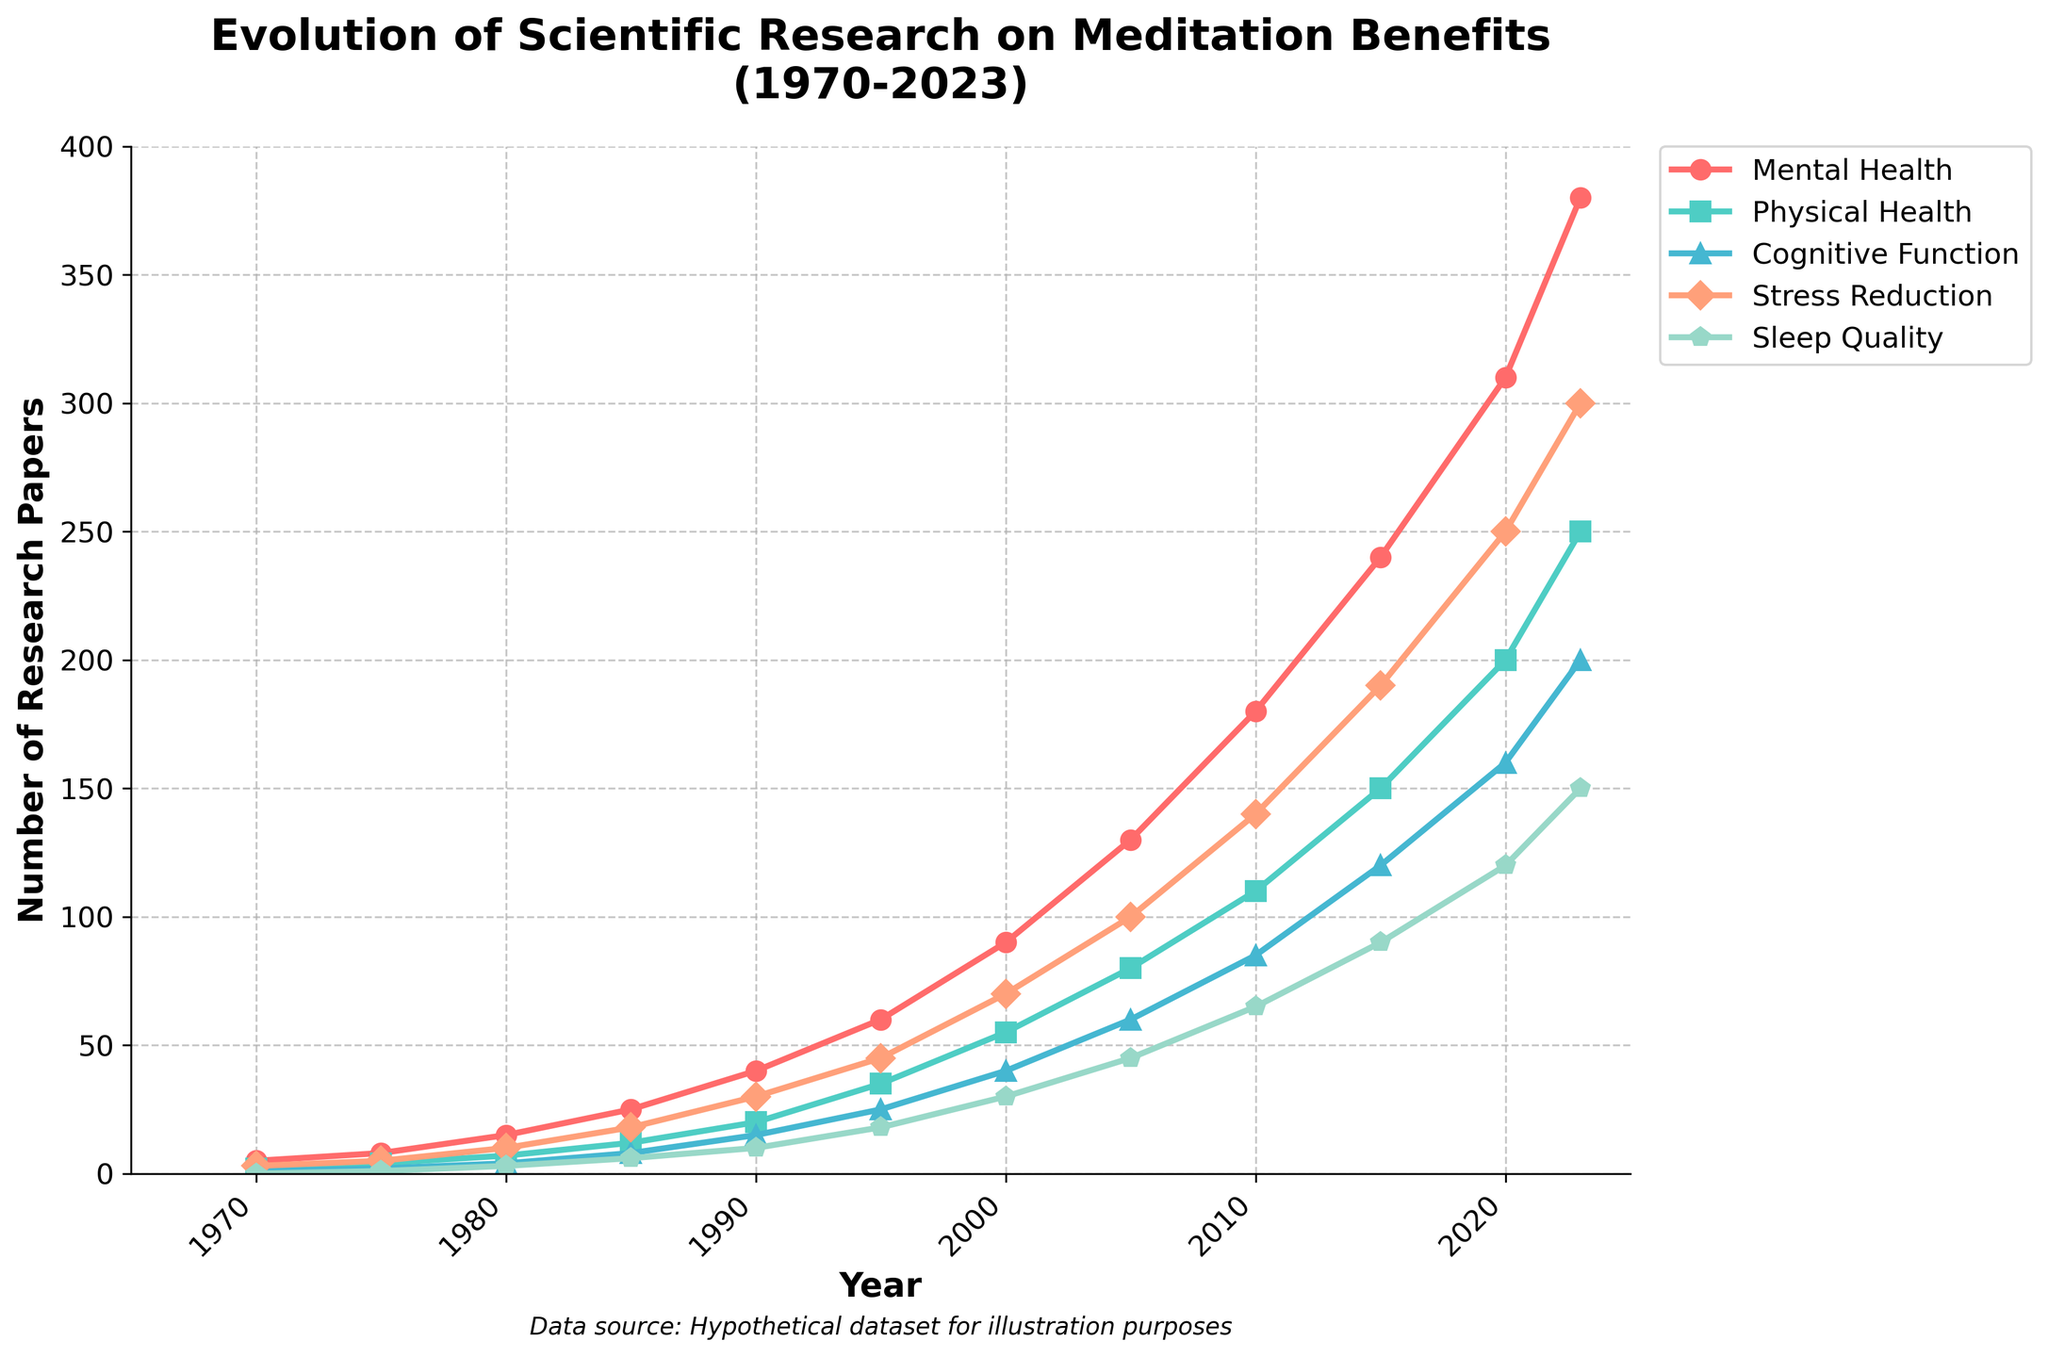What's the health domain with the highest number of research papers published in 2023? Look at the last data point on the line chart for each health domain in 2023. The line with the highest last data point value is Mental Health.
Answer: Mental Health How many more research papers were published on Mental Health than on Stress Reduction in 2020? In 2020, trace the data points for Mental Health and Stress Reduction. They are 310 and 250, respectively. The difference is 310 - 250.
Answer: 60 Which health domain shows the greatest overall increase in the number of research papers from 1970 to 2023? Compare the increase from 1970 to 2023 for each health domain by subtracting the 1970 data point from the 2023 data point for all domains. Mental Health has the greatest increase: 380 - 5.
Answer: Mental Health Between which two adjacent years did Physical Health see the largest increase in the number of research papers published? Check the increments between adjacent years for Physical Health. The largest increment is between the years 2020 (200 papers) and 2023 (250 papers), a difference of 50 papers.
Answer: 2020 and 2023 What is the average number of research papers published on Sleep Quality from 1980 to 1990? Add up the numbers of papers for Sleep Quality from 1980, 1985, and 1990 (3, 6, and 10) and then divide by the total number of years (3). (3+6+10)/3 = 19/3 = 6.33.
Answer: 6.33 Is the number of research papers published on Cognitive Function in 2000 greater than the total of those published on Mental Health and Physical Health in 1975? The number for Cognitive Function in 2000 is 40. The sum of papers on Mental Health and Physical Health in 1975 is 8 + 4 = 12. 40 is indeed greater than 12.
Answer: Yes Which health domain had the least number of research papers in 1985? Look at the data points for all health domains in 1985 and identify the smallest value. Sleep Quality had the least with 6 papers.
Answer: Sleep Quality What is the total number of research papers published across all health domains in 1990? Add up the number of papers in 1990 for each domain: 40 (Mental Health) + 20 (Physical Health) + 15 (Cognitive Function) + 30 (Stress Reduction) + 10 (Sleep Quality) = 115.
Answer: 115 